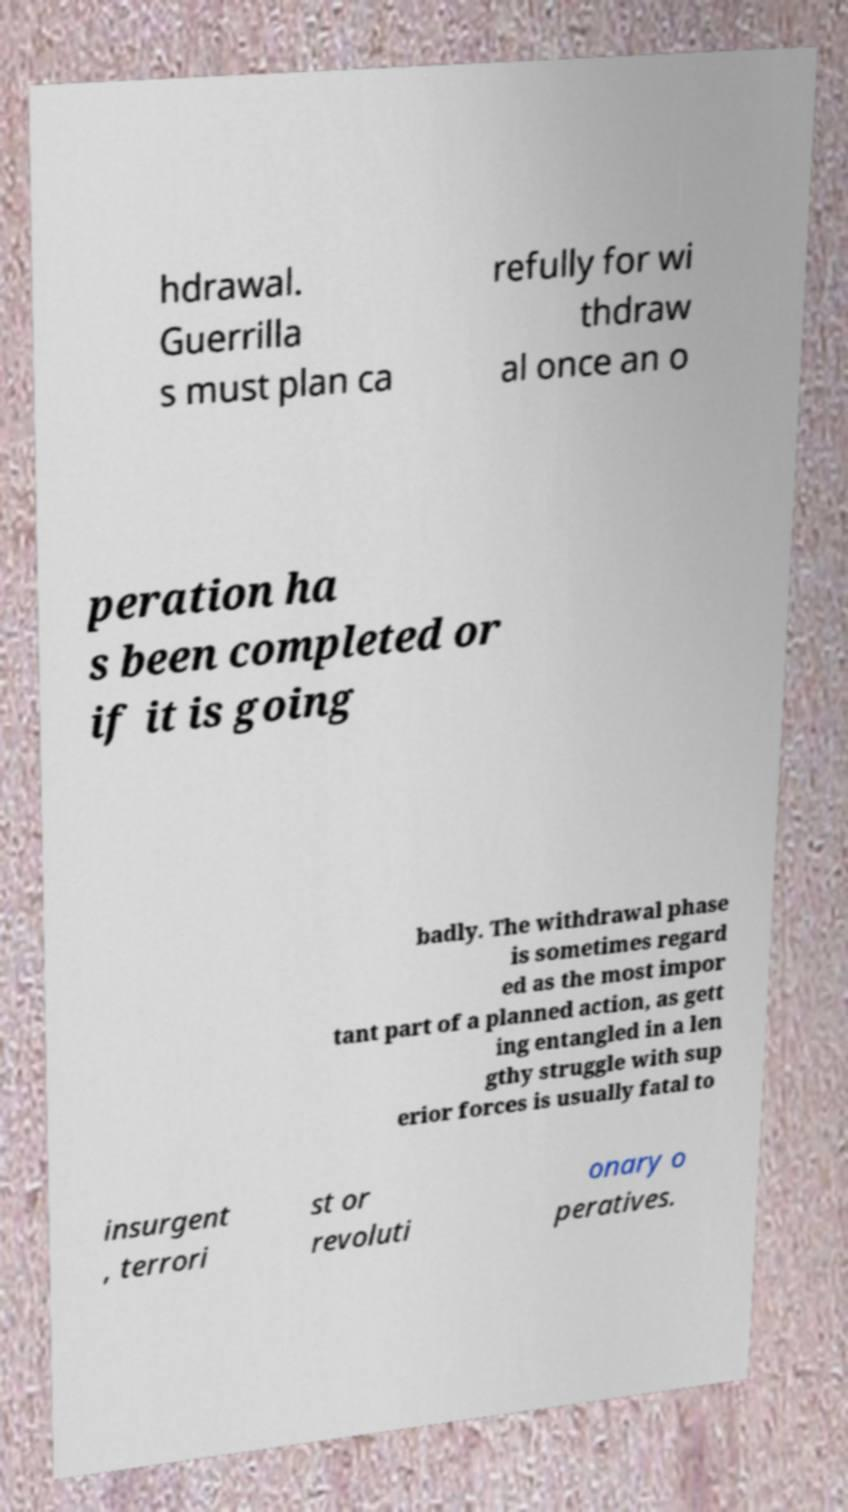Can you accurately transcribe the text from the provided image for me? hdrawal. Guerrilla s must plan ca refully for wi thdraw al once an o peration ha s been completed or if it is going badly. The withdrawal phase is sometimes regard ed as the most impor tant part of a planned action, as gett ing entangled in a len gthy struggle with sup erior forces is usually fatal to insurgent , terrori st or revoluti onary o peratives. 